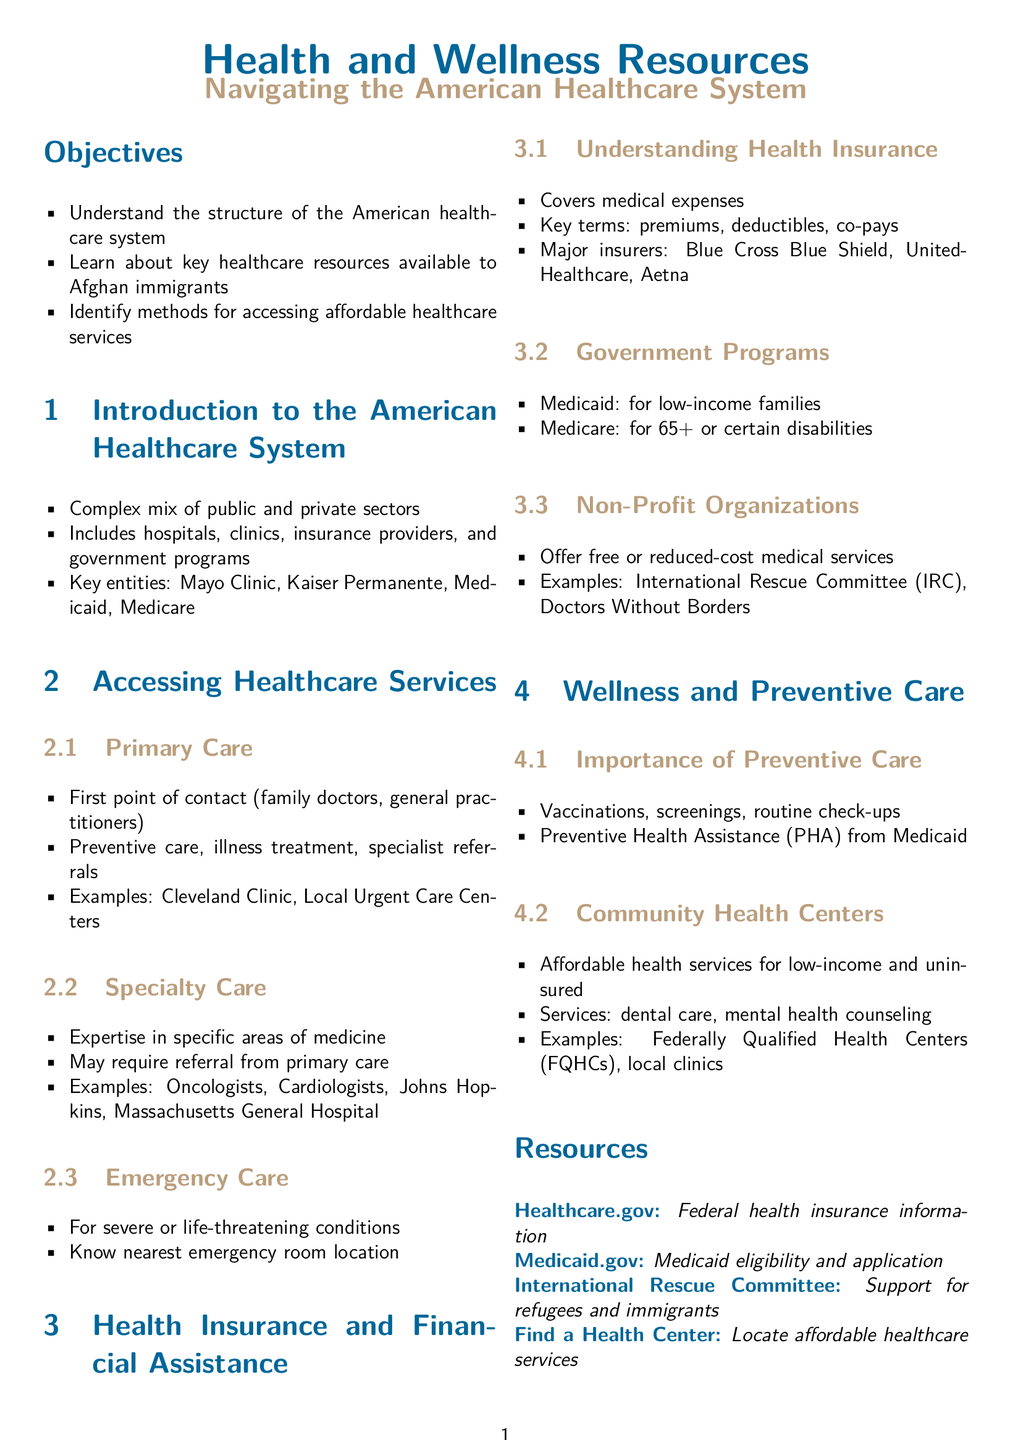what is the main focus of the lesson? The main focus is to navigate the American healthcare system, emphasizing understanding resources available to Afghan immigrants.
Answer: navigating the American healthcare system what type of care do family doctors provide? Family doctors are the first point of contact and provide preventive care, illness treatment, and specialist referrals.
Answer: preventive care, illness treatment, specialist referrals which government program is for low-income families? The document mentions that Medicaid is specifically designed for low-income families.
Answer: Medicaid what is an example of a non-profit organization mentioned? The document specifically lists organizations like the International Rescue Committee and Doctors Without Borders as examples.
Answer: International Rescue Committee how can someone locate affordable healthcare services? The document suggests using the resource "Find a Health Center" to locate these services.
Answer: Find a Health Center what is the importance of preventive care according to the document? The document states that preventive care includes vaccinations, screenings, and routine check-ups, crucial for health maintenance.
Answer: vaccinations, screenings, routine check-ups who qualifies for Medicare? The document notes that Medicare is for individuals aged 65 and older or those with certain disabilities.
Answer: 65+ or certain disabilities what type of insurance covers medical expenses? The document explains that health insurance is designed to cover medical expenses for individuals and families.
Answer: health insurance 